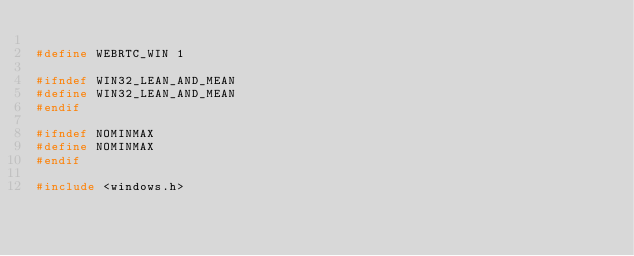<code> <loc_0><loc_0><loc_500><loc_500><_C_>
#define WEBRTC_WIN 1

#ifndef WIN32_LEAN_AND_MEAN
#define WIN32_LEAN_AND_MEAN
#endif

#ifndef NOMINMAX
#define NOMINMAX
#endif

#include <windows.h>
</code> 